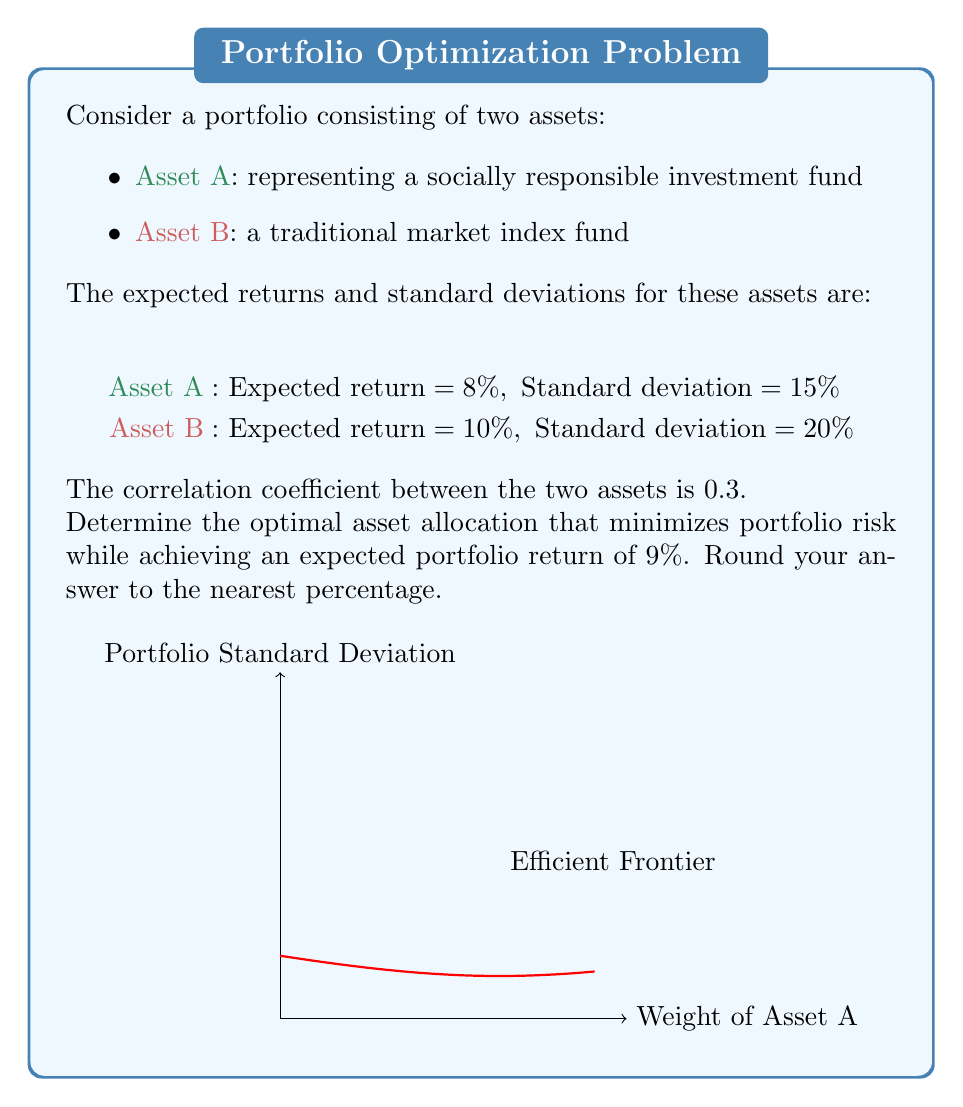Can you solve this math problem? To solve this problem using Modern Portfolio Theory, we'll follow these steps:

1) First, let's define our variables:
   $w_A$ = weight of Asset A
   $w_B$ = weight of Asset B (note that $w_B = 1 - w_A$)

2) The expected portfolio return is given by:
   $$E(R_p) = w_A E(R_A) + w_B E(R_B)$$

3) The portfolio variance is given by:
   $$\sigma_p^2 = w_A^2 \sigma_A^2 + w_B^2 \sigma_B^2 + 2w_A w_B \sigma_A \sigma_B \rho_{AB}$$

   where $\rho_{AB}$ is the correlation coefficient between A and B.

4) We want to achieve an expected return of 9%, so:
   $$0.09 = 0.08w_A + 0.10(1-w_A)$$

5) Solving this equation:
   $$0.09 = 0.08w_A + 0.10 - 0.10w_A$$
   $$0.09 = 0.10 - 0.02w_A$$
   $$-0.01 = -0.02w_A$$
   $$w_A = 0.5$$

6) Therefore, $w_B = 1 - w_A = 0.5$

7) To verify this minimizes risk, we can calculate the portfolio standard deviation:
   $$\sigma_p = \sqrt{0.5^2 (0.15^2) + 0.5^2 (0.20^2) + 2(0.5)(0.5)(0.15)(0.20)(0.3)}$$
   $$= \sqrt{0.0056 + 0.01 + 0.0045} = \sqrt{0.0201} = 0.1417 = 14.17\%$$

This allocation achieves the target return while minimizing risk, as any other allocation with the same expected return would result in a higher standard deviation.
Answer: 50% in Asset A, 50% in Asset B 